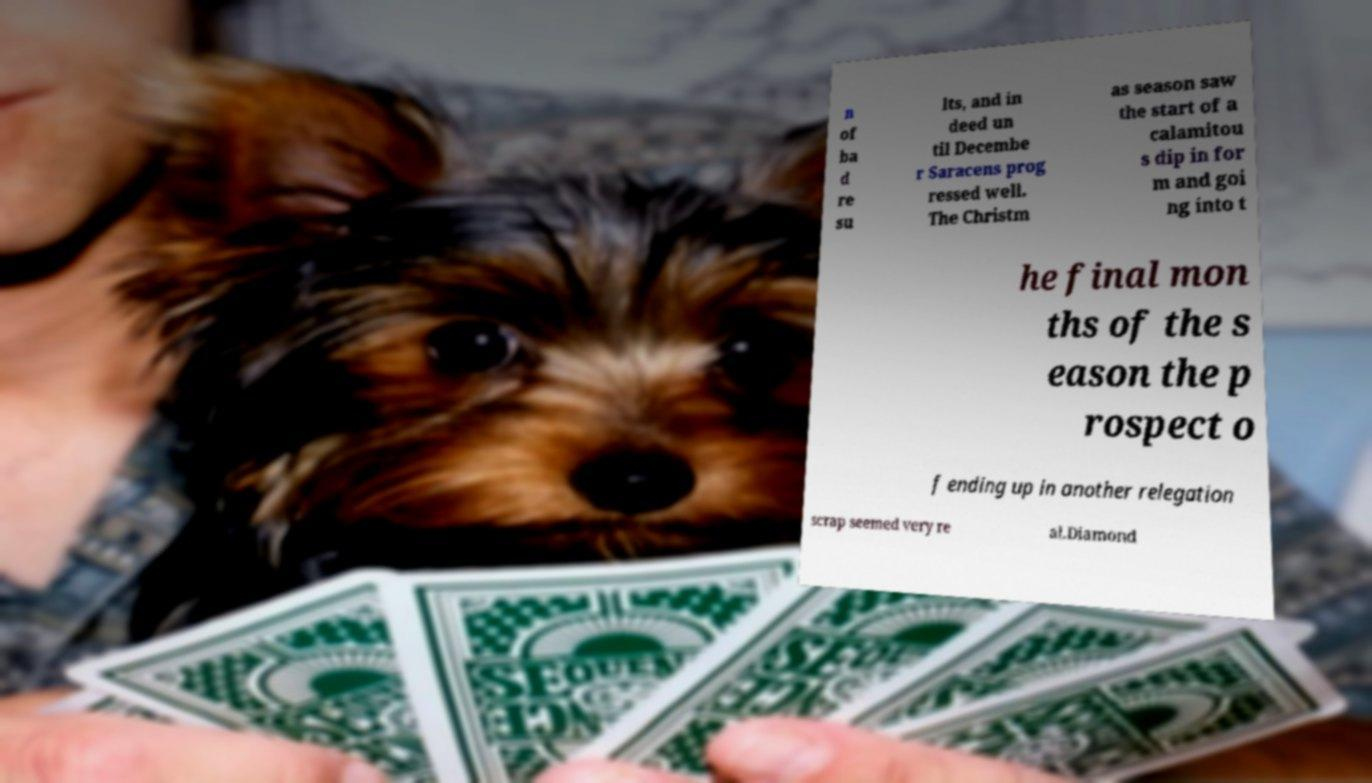Please read and relay the text visible in this image. What does it say? n of ba d re su lts, and in deed un til Decembe r Saracens prog ressed well. The Christm as season saw the start of a calamitou s dip in for m and goi ng into t he final mon ths of the s eason the p rospect o f ending up in another relegation scrap seemed very re al.Diamond 